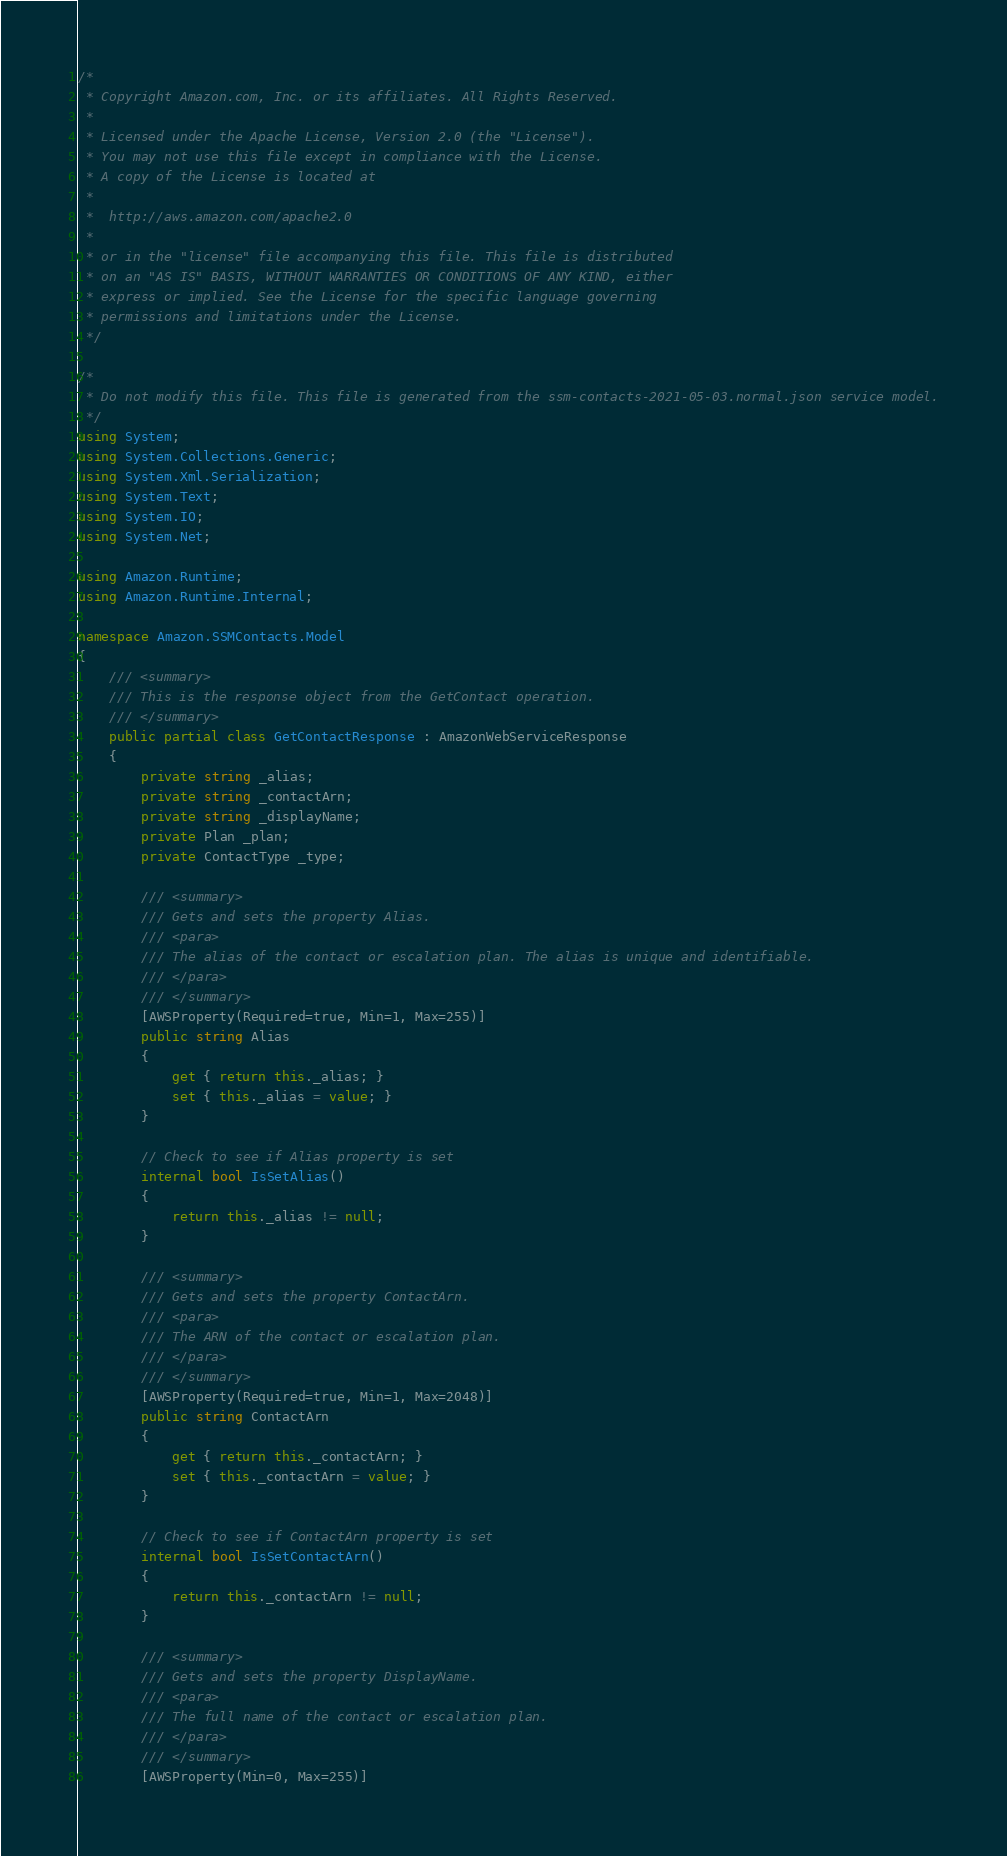<code> <loc_0><loc_0><loc_500><loc_500><_C#_>/*
 * Copyright Amazon.com, Inc. or its affiliates. All Rights Reserved.
 * 
 * Licensed under the Apache License, Version 2.0 (the "License").
 * You may not use this file except in compliance with the License.
 * A copy of the License is located at
 * 
 *  http://aws.amazon.com/apache2.0
 * 
 * or in the "license" file accompanying this file. This file is distributed
 * on an "AS IS" BASIS, WITHOUT WARRANTIES OR CONDITIONS OF ANY KIND, either
 * express or implied. See the License for the specific language governing
 * permissions and limitations under the License.
 */

/*
 * Do not modify this file. This file is generated from the ssm-contacts-2021-05-03.normal.json service model.
 */
using System;
using System.Collections.Generic;
using System.Xml.Serialization;
using System.Text;
using System.IO;
using System.Net;

using Amazon.Runtime;
using Amazon.Runtime.Internal;

namespace Amazon.SSMContacts.Model
{
    /// <summary>
    /// This is the response object from the GetContact operation.
    /// </summary>
    public partial class GetContactResponse : AmazonWebServiceResponse
    {
        private string _alias;
        private string _contactArn;
        private string _displayName;
        private Plan _plan;
        private ContactType _type;

        /// <summary>
        /// Gets and sets the property Alias. 
        /// <para>
        /// The alias of the contact or escalation plan. The alias is unique and identifiable.
        /// </para>
        /// </summary>
        [AWSProperty(Required=true, Min=1, Max=255)]
        public string Alias
        {
            get { return this._alias; }
            set { this._alias = value; }
        }

        // Check to see if Alias property is set
        internal bool IsSetAlias()
        {
            return this._alias != null;
        }

        /// <summary>
        /// Gets and sets the property ContactArn. 
        /// <para>
        /// The ARN of the contact or escalation plan.
        /// </para>
        /// </summary>
        [AWSProperty(Required=true, Min=1, Max=2048)]
        public string ContactArn
        {
            get { return this._contactArn; }
            set { this._contactArn = value; }
        }

        // Check to see if ContactArn property is set
        internal bool IsSetContactArn()
        {
            return this._contactArn != null;
        }

        /// <summary>
        /// Gets and sets the property DisplayName. 
        /// <para>
        /// The full name of the contact or escalation plan.
        /// </para>
        /// </summary>
        [AWSProperty(Min=0, Max=255)]</code> 